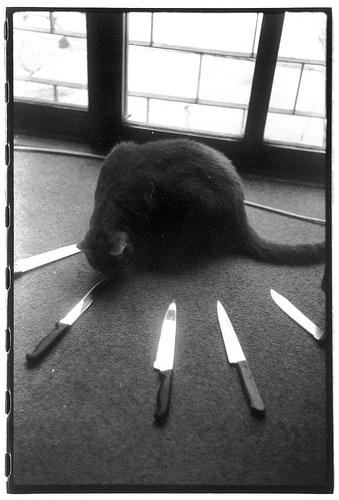What is surrounding the cat?

Choices:
A) knives
B) dogs
C) penguins
D) foxes knives 